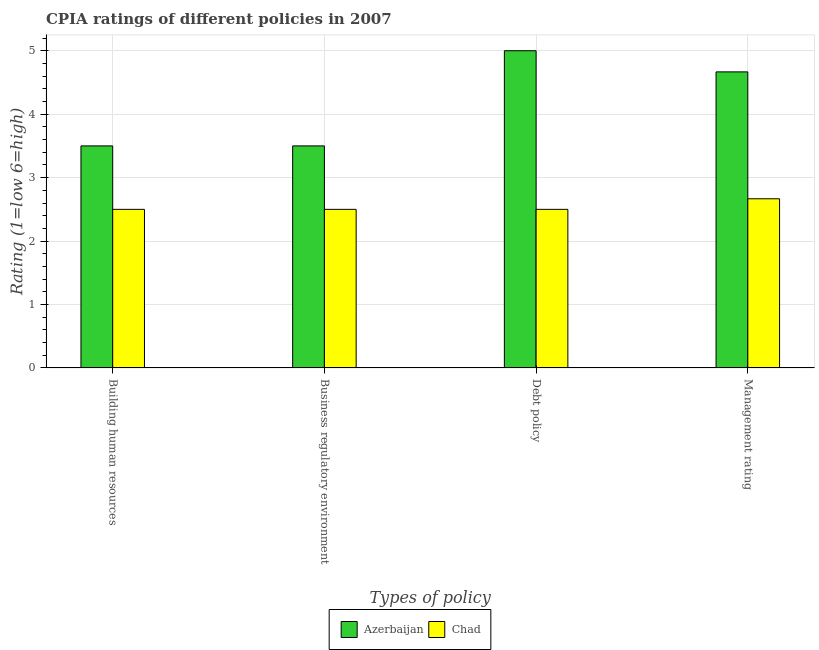How many different coloured bars are there?
Ensure brevity in your answer.  2. How many bars are there on the 1st tick from the left?
Provide a short and direct response. 2. What is the label of the 2nd group of bars from the left?
Offer a very short reply. Business regulatory environment. What is the cpia rating of management in Azerbaijan?
Give a very brief answer. 4.67. Across all countries, what is the maximum cpia rating of management?
Your answer should be very brief. 4.67. In which country was the cpia rating of business regulatory environment maximum?
Provide a succinct answer. Azerbaijan. In which country was the cpia rating of building human resources minimum?
Offer a terse response. Chad. What is the difference between the cpia rating of business regulatory environment in Azerbaijan and the cpia rating of debt policy in Chad?
Provide a succinct answer. 1. What is the average cpia rating of business regulatory environment per country?
Your answer should be compact. 3. In how many countries, is the cpia rating of building human resources greater than 2 ?
Provide a short and direct response. 2. What is the ratio of the cpia rating of building human resources in Azerbaijan to that in Chad?
Keep it short and to the point. 1.4. What is the difference between the highest and the second highest cpia rating of building human resources?
Provide a succinct answer. 1. What is the difference between the highest and the lowest cpia rating of management?
Your answer should be very brief. 2. Is the sum of the cpia rating of management in Chad and Azerbaijan greater than the maximum cpia rating of debt policy across all countries?
Your answer should be compact. Yes. Is it the case that in every country, the sum of the cpia rating of debt policy and cpia rating of management is greater than the sum of cpia rating of business regulatory environment and cpia rating of building human resources?
Provide a succinct answer. No. What does the 2nd bar from the left in Debt policy represents?
Make the answer very short. Chad. What does the 2nd bar from the right in Management rating represents?
Ensure brevity in your answer.  Azerbaijan. How many bars are there?
Ensure brevity in your answer.  8. How many countries are there in the graph?
Provide a succinct answer. 2. What is the difference between two consecutive major ticks on the Y-axis?
Provide a succinct answer. 1. Does the graph contain any zero values?
Provide a succinct answer. No. Where does the legend appear in the graph?
Your answer should be very brief. Bottom center. How many legend labels are there?
Provide a succinct answer. 2. What is the title of the graph?
Your answer should be compact. CPIA ratings of different policies in 2007. What is the label or title of the X-axis?
Provide a short and direct response. Types of policy. What is the Rating (1=low 6=high) in Chad in Building human resources?
Offer a terse response. 2.5. What is the Rating (1=low 6=high) of Chad in Debt policy?
Provide a succinct answer. 2.5. What is the Rating (1=low 6=high) of Azerbaijan in Management rating?
Offer a terse response. 4.67. What is the Rating (1=low 6=high) of Chad in Management rating?
Your answer should be very brief. 2.67. Across all Types of policy, what is the maximum Rating (1=low 6=high) in Chad?
Your answer should be compact. 2.67. What is the total Rating (1=low 6=high) in Azerbaijan in the graph?
Give a very brief answer. 16.67. What is the total Rating (1=low 6=high) in Chad in the graph?
Provide a succinct answer. 10.17. What is the difference between the Rating (1=low 6=high) of Azerbaijan in Building human resources and that in Management rating?
Offer a terse response. -1.17. What is the difference between the Rating (1=low 6=high) of Azerbaijan in Business regulatory environment and that in Debt policy?
Give a very brief answer. -1.5. What is the difference between the Rating (1=low 6=high) in Chad in Business regulatory environment and that in Debt policy?
Keep it short and to the point. 0. What is the difference between the Rating (1=low 6=high) of Azerbaijan in Business regulatory environment and that in Management rating?
Your response must be concise. -1.17. What is the difference between the Rating (1=low 6=high) of Chad in Business regulatory environment and that in Management rating?
Keep it short and to the point. -0.17. What is the difference between the Rating (1=low 6=high) in Azerbaijan in Building human resources and the Rating (1=low 6=high) in Chad in Debt policy?
Offer a very short reply. 1. What is the difference between the Rating (1=low 6=high) in Azerbaijan in Building human resources and the Rating (1=low 6=high) in Chad in Management rating?
Offer a very short reply. 0.83. What is the difference between the Rating (1=low 6=high) of Azerbaijan in Business regulatory environment and the Rating (1=low 6=high) of Chad in Debt policy?
Your answer should be very brief. 1. What is the difference between the Rating (1=low 6=high) in Azerbaijan in Debt policy and the Rating (1=low 6=high) in Chad in Management rating?
Give a very brief answer. 2.33. What is the average Rating (1=low 6=high) of Azerbaijan per Types of policy?
Offer a very short reply. 4.17. What is the average Rating (1=low 6=high) of Chad per Types of policy?
Keep it short and to the point. 2.54. What is the difference between the Rating (1=low 6=high) in Azerbaijan and Rating (1=low 6=high) in Chad in Building human resources?
Offer a terse response. 1. What is the difference between the Rating (1=low 6=high) in Azerbaijan and Rating (1=low 6=high) in Chad in Business regulatory environment?
Your response must be concise. 1. What is the difference between the Rating (1=low 6=high) in Azerbaijan and Rating (1=low 6=high) in Chad in Debt policy?
Give a very brief answer. 2.5. What is the difference between the Rating (1=low 6=high) of Azerbaijan and Rating (1=low 6=high) of Chad in Management rating?
Your answer should be compact. 2. What is the ratio of the Rating (1=low 6=high) in Azerbaijan in Building human resources to that in Business regulatory environment?
Your response must be concise. 1. What is the ratio of the Rating (1=low 6=high) of Chad in Building human resources to that in Business regulatory environment?
Provide a succinct answer. 1. What is the ratio of the Rating (1=low 6=high) in Azerbaijan in Building human resources to that in Management rating?
Your response must be concise. 0.75. What is the ratio of the Rating (1=low 6=high) of Chad in Business regulatory environment to that in Debt policy?
Your answer should be compact. 1. What is the ratio of the Rating (1=low 6=high) of Azerbaijan in Business regulatory environment to that in Management rating?
Provide a succinct answer. 0.75. What is the ratio of the Rating (1=low 6=high) in Chad in Business regulatory environment to that in Management rating?
Ensure brevity in your answer.  0.94. What is the ratio of the Rating (1=low 6=high) of Azerbaijan in Debt policy to that in Management rating?
Your response must be concise. 1.07. What is the ratio of the Rating (1=low 6=high) of Chad in Debt policy to that in Management rating?
Your answer should be very brief. 0.94. What is the difference between the highest and the second highest Rating (1=low 6=high) of Azerbaijan?
Your response must be concise. 0.33. What is the difference between the highest and the second highest Rating (1=low 6=high) in Chad?
Keep it short and to the point. 0.17. 